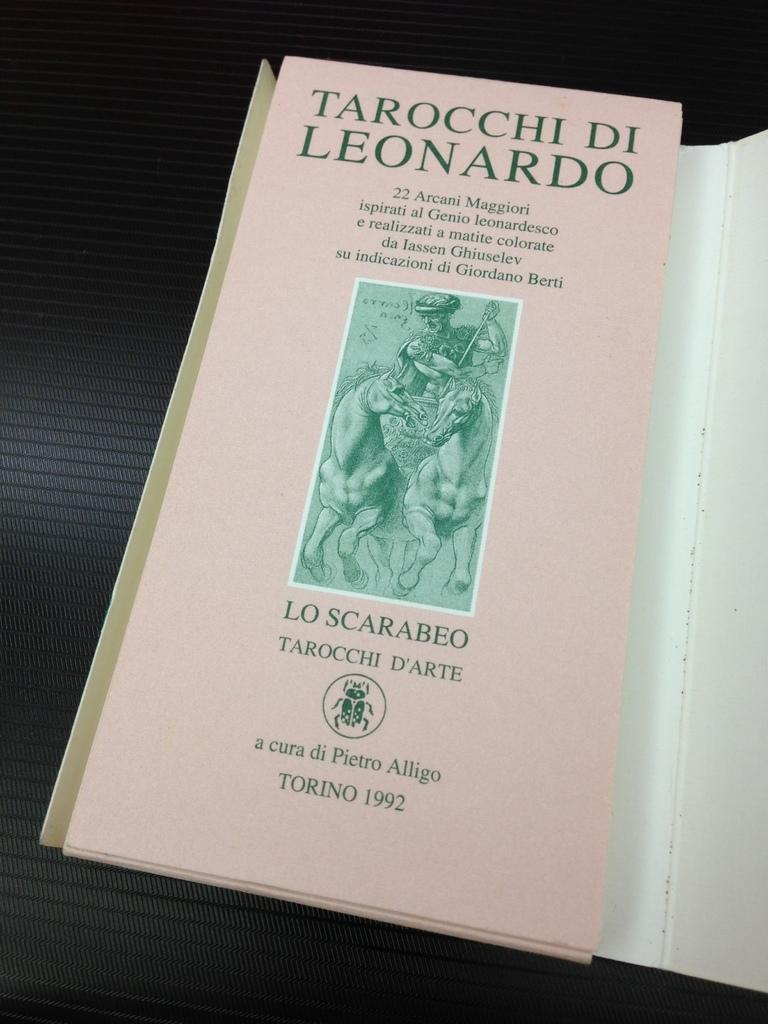<image>
Create a compact narrative representing the image presented. Pmaphlet by Torino 1992 with green letterin Tarocchi Di Leonardo 